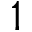<formula> <loc_0><loc_0><loc_500><loc_500>1</formula> 